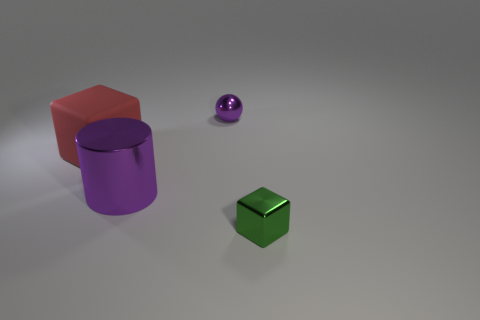Add 4 big yellow blocks. How many objects exist? 8 Subtract all red cylinders. Subtract all blue balls. How many cylinders are left? 1 Subtract all green balls. How many green blocks are left? 1 Subtract all yellow metallic balls. Subtract all big cylinders. How many objects are left? 3 Add 3 tiny green metal objects. How many tiny green metal objects are left? 4 Add 1 small gray metal objects. How many small gray metal objects exist? 1 Subtract 0 gray cylinders. How many objects are left? 4 Subtract 2 cubes. How many cubes are left? 0 